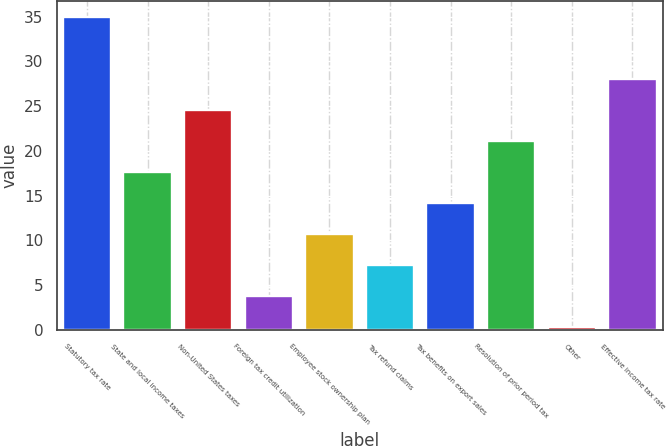<chart> <loc_0><loc_0><loc_500><loc_500><bar_chart><fcel>Statutory tax rate<fcel>State and local income taxes<fcel>Non-United States taxes<fcel>Foreign tax credit utilization<fcel>Employee stock ownership plan<fcel>Tax refund claims<fcel>Tax benefits on export sales<fcel>Resolution of prior period tax<fcel>Other<fcel>Effective income tax rate<nl><fcel>35<fcel>17.65<fcel>24.59<fcel>3.77<fcel>10.71<fcel>7.24<fcel>14.18<fcel>21.12<fcel>0.3<fcel>28.06<nl></chart> 